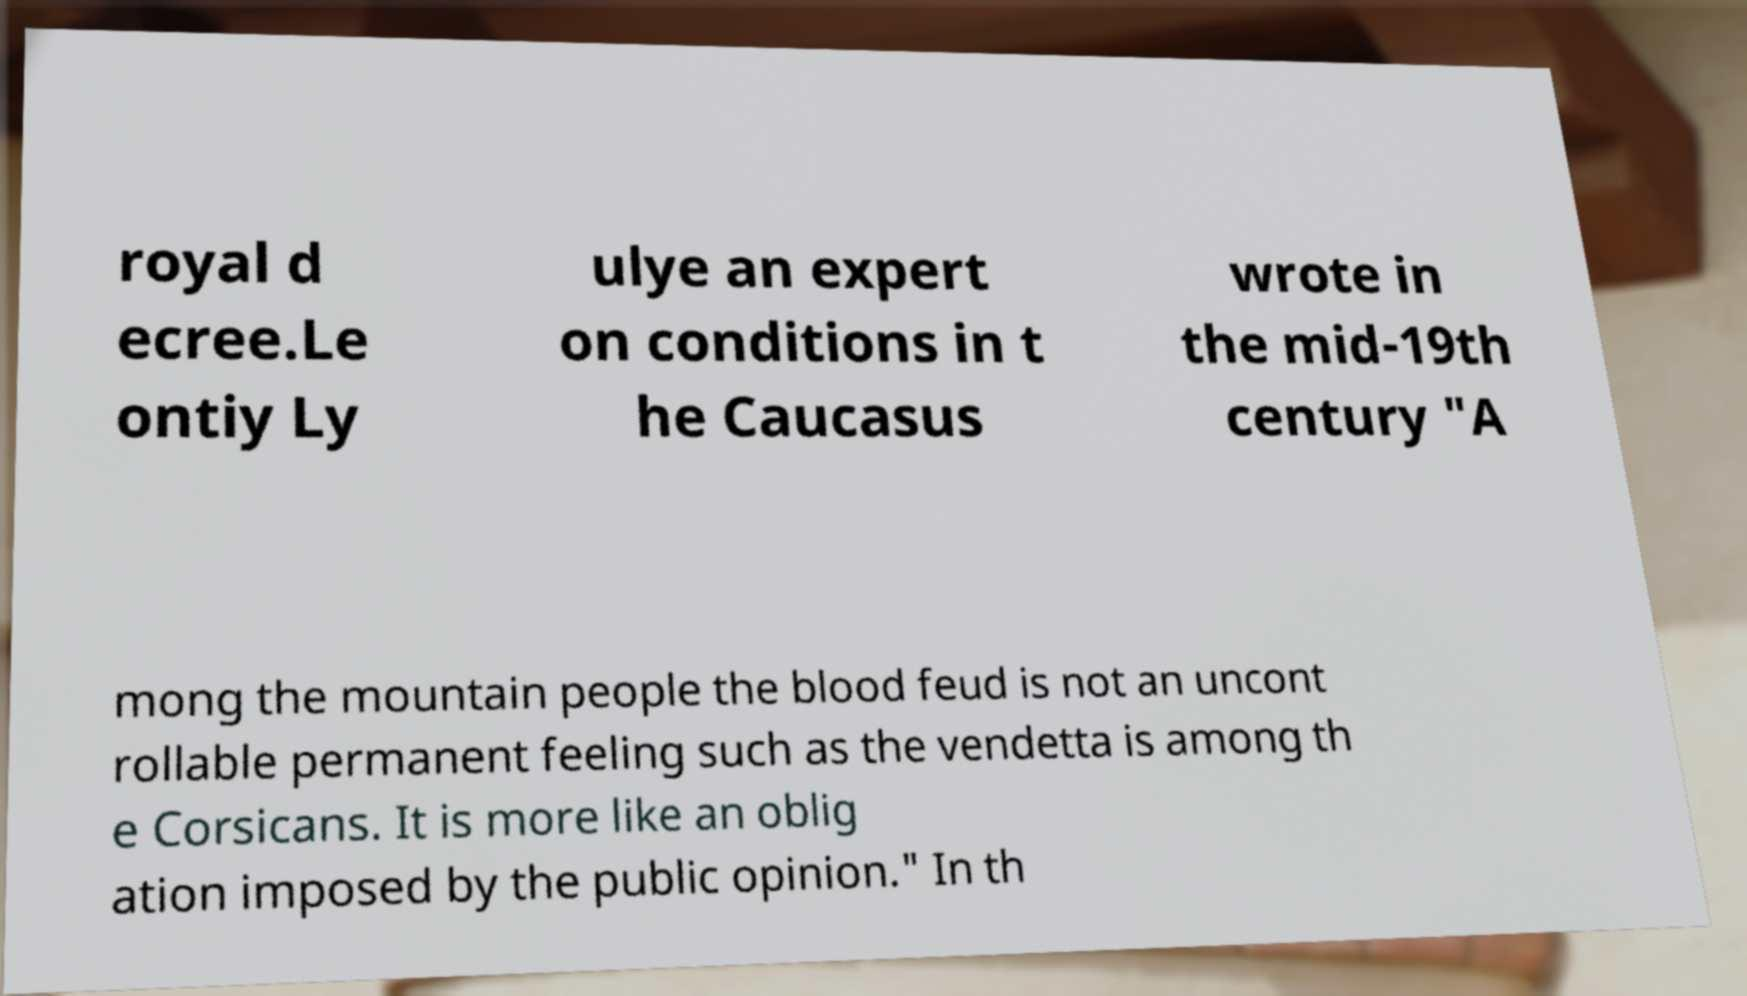There's text embedded in this image that I need extracted. Can you transcribe it verbatim? royal d ecree.Le ontiy Ly ulye an expert on conditions in t he Caucasus wrote in the mid-19th century "A mong the mountain people the blood feud is not an uncont rollable permanent feeling such as the vendetta is among th e Corsicans. It is more like an oblig ation imposed by the public opinion." In th 